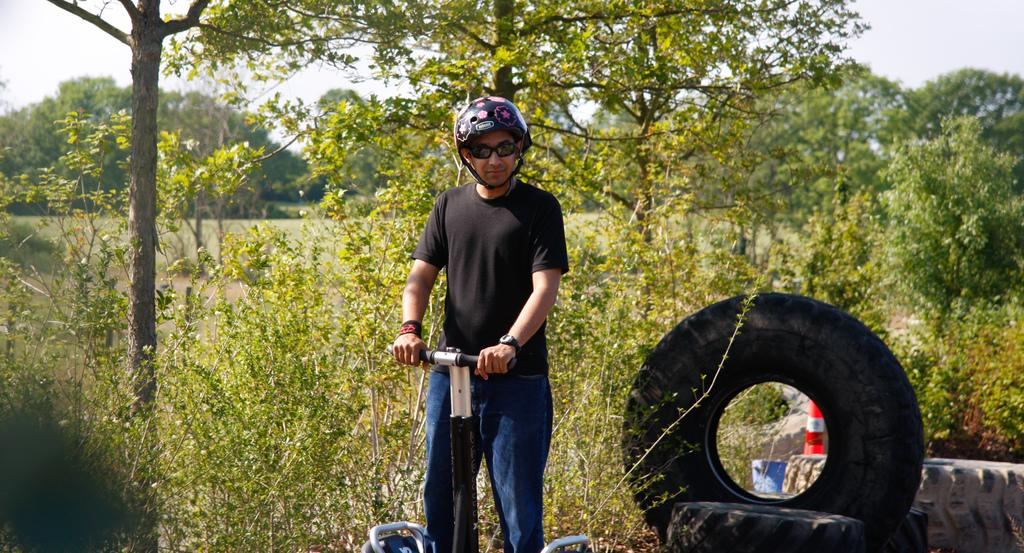Who is present in the image? There is a man in the image. What is the man doing or with what is he associated? The man is with a scooter. What can be seen on the right side of the man? There are tyres and an object on the right side of the man. What is visible in the background of the image? Trees and the sky are visible in the background of the image. What type of instrument is the man playing in the image? There is no instrument present in the image; the man is with a scooter. Can you see any cows in the image? No, there are no cows present in the image. 